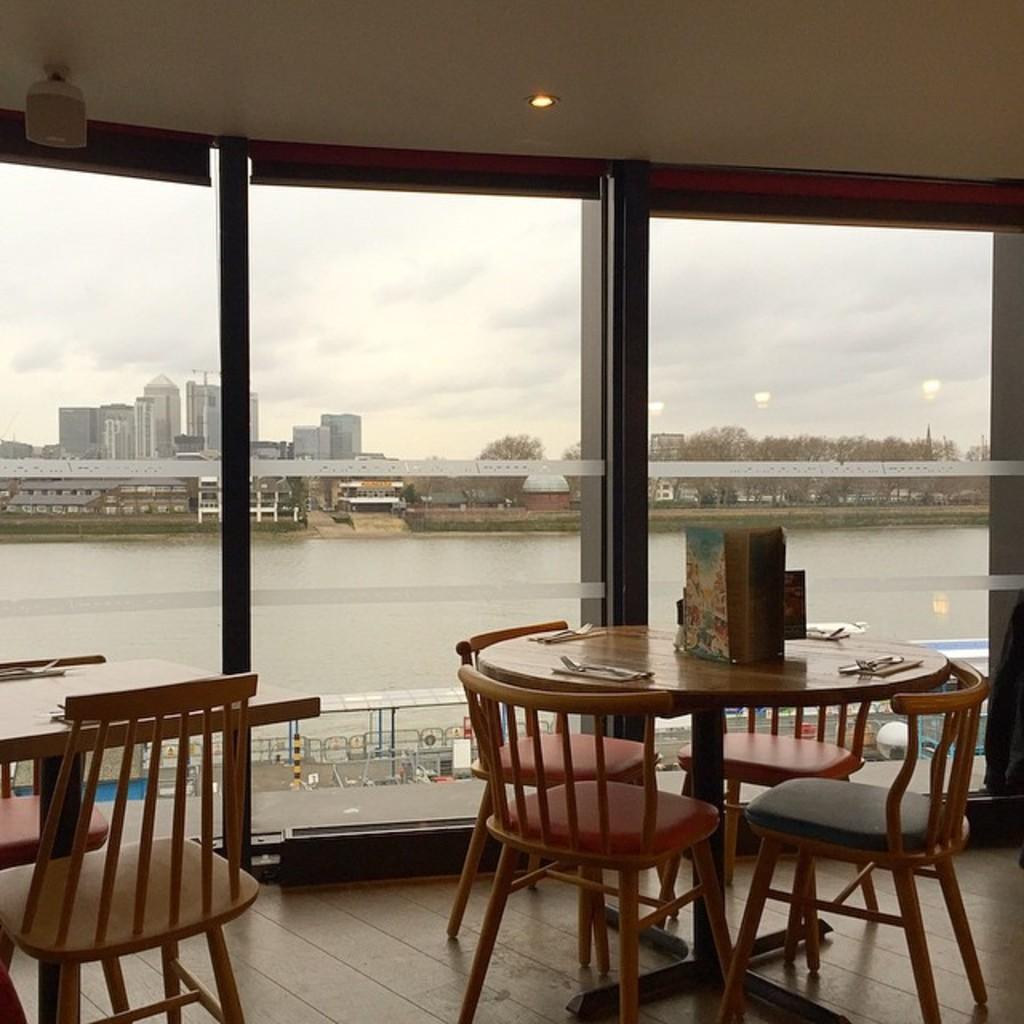Can you describe this image briefly? In this image there are tables around the tables there are chairs, in the background there are glass doors through that doors lake, trees, buildings and the sky are visible. 